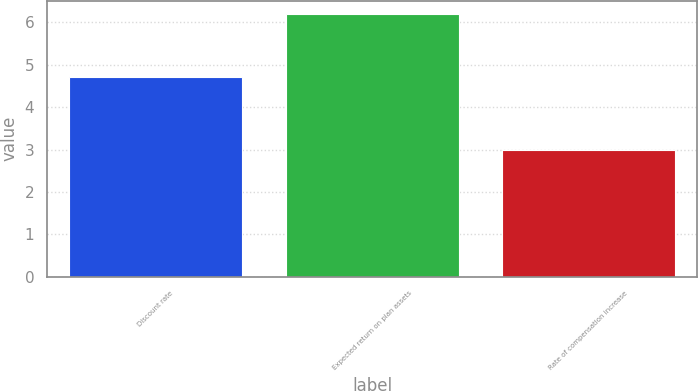<chart> <loc_0><loc_0><loc_500><loc_500><bar_chart><fcel>Discount rate<fcel>Expected return on plan assets<fcel>Rate of compensation increase<nl><fcel>4.7<fcel>6.2<fcel>3<nl></chart> 